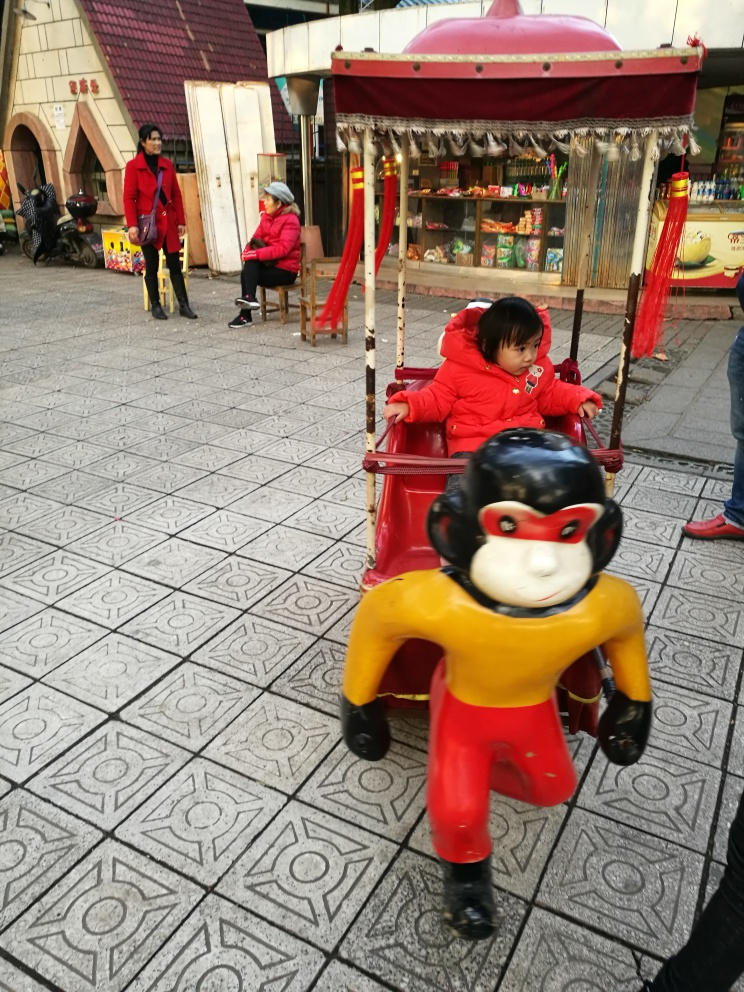What cultural elements can be observed in this image? The image shows a traditional outdoor market setting that includes vending stalls and small rides typical in many cultures, offering a glimpse into local life and community interactions. 